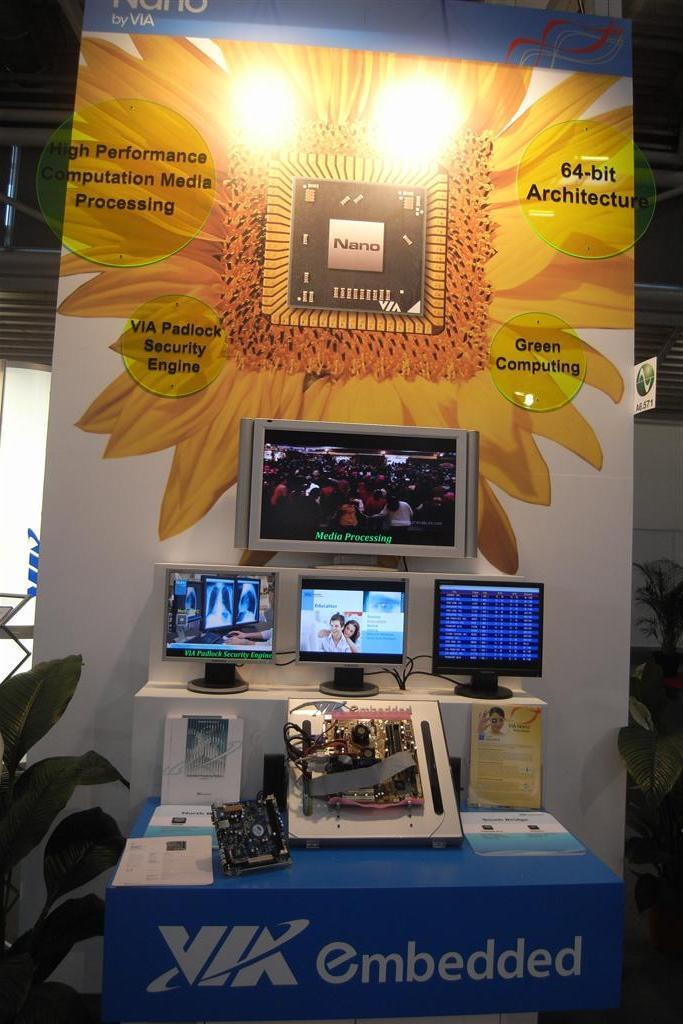<image>
Share a concise interpretation of the image provided. A display for 64 bit architecture computational processing. 